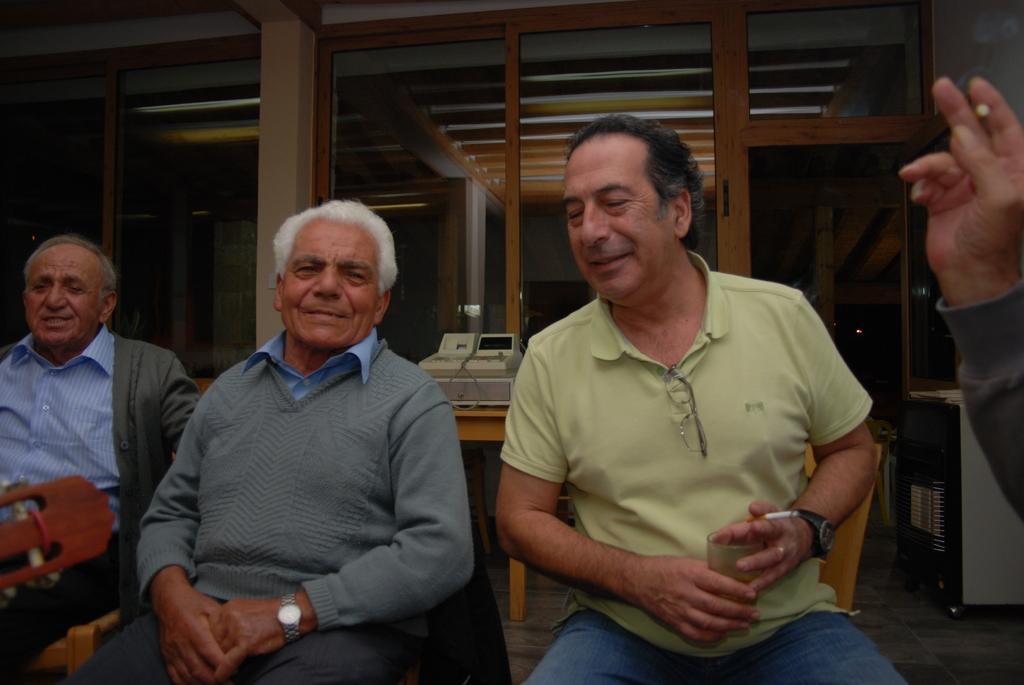Can you describe this image briefly? In this image, we can see three persons wearing clothes. There is a person in the middle of the image holding a glass and cigarette. There is a person hand on the right side of the image. 